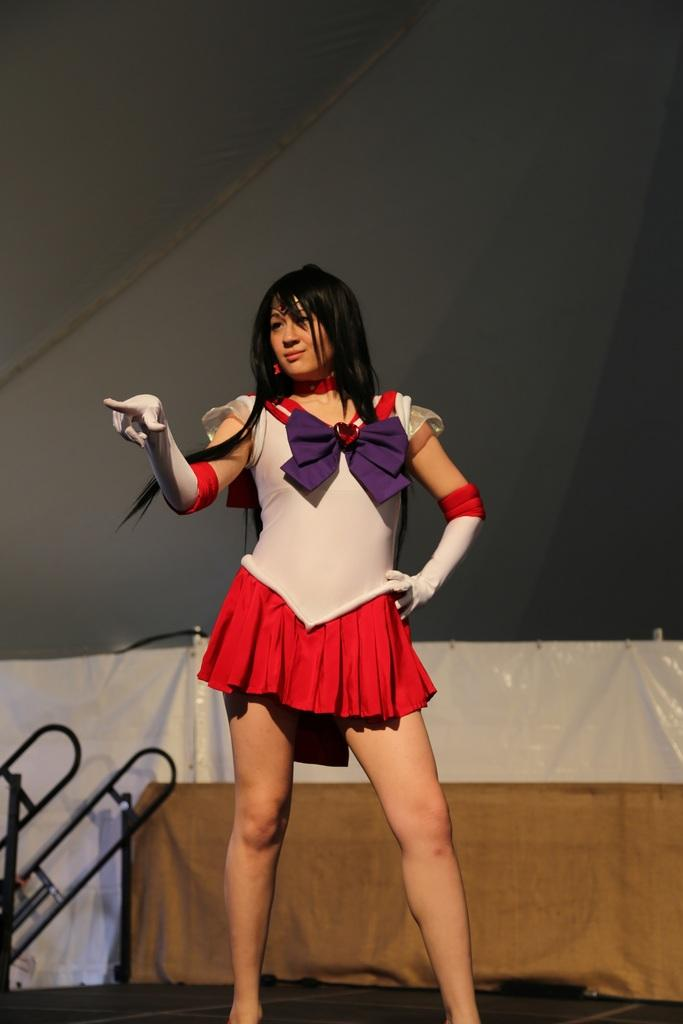Who or what is in the image? There is a person in the image. Where is the person located? The person is on a path. What can be seen behind the person? There is a cloth visible behind the person, as well as other unspecified things. What type of substance is the crow using to fly in the image? There is no crow present in the image, so it is not possible to determine what substance might be used for flying. 